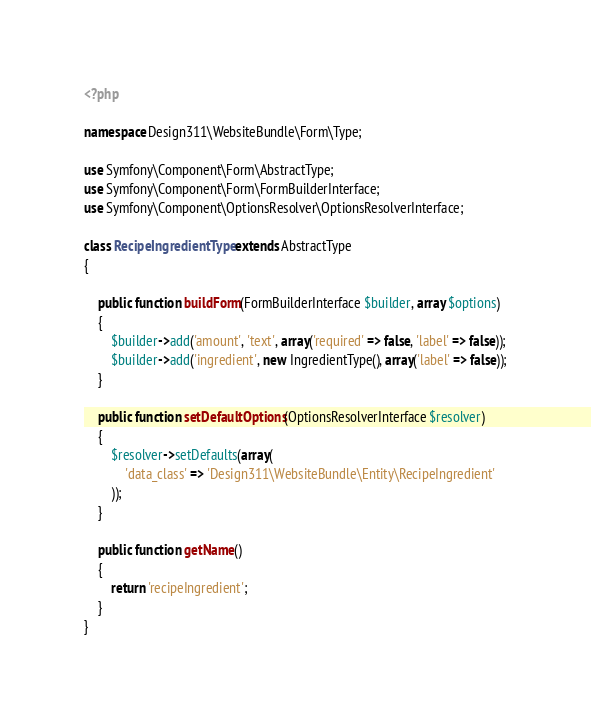Convert code to text. <code><loc_0><loc_0><loc_500><loc_500><_PHP_><?php 

namespace Design311\WebsiteBundle\Form\Type;

use Symfony\Component\Form\AbstractType;
use Symfony\Component\Form\FormBuilderInterface;
use Symfony\Component\OptionsResolver\OptionsResolverInterface;

class RecipeIngredientType extends AbstractType
{

    public function buildForm(FormBuilderInterface $builder, array $options)
    {
        $builder->add('amount', 'text', array('required' => false, 'label' => false));
        $builder->add('ingredient', new IngredientType(), array('label' => false));
    }

    public function setDefaultOptions(OptionsResolverInterface $resolver)
    {
        $resolver->setDefaults(array(
            'data_class' => 'Design311\WebsiteBundle\Entity\RecipeIngredient'
        ));
    }

    public function getName()
    {
        return 'recipeIngredient';
    }
}</code> 